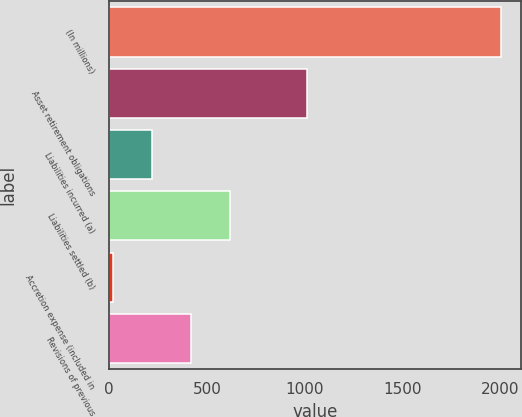Convert chart. <chart><loc_0><loc_0><loc_500><loc_500><bar_chart><fcel>(In millions)<fcel>Asset retirement obligations<fcel>Liabilities incurred (a)<fcel>Liabilities settled (b)<fcel>Accretion expense (included in<fcel>Revisions of previous<nl><fcel>2003<fcel>1011.5<fcel>218.3<fcel>614.9<fcel>20<fcel>416.6<nl></chart> 